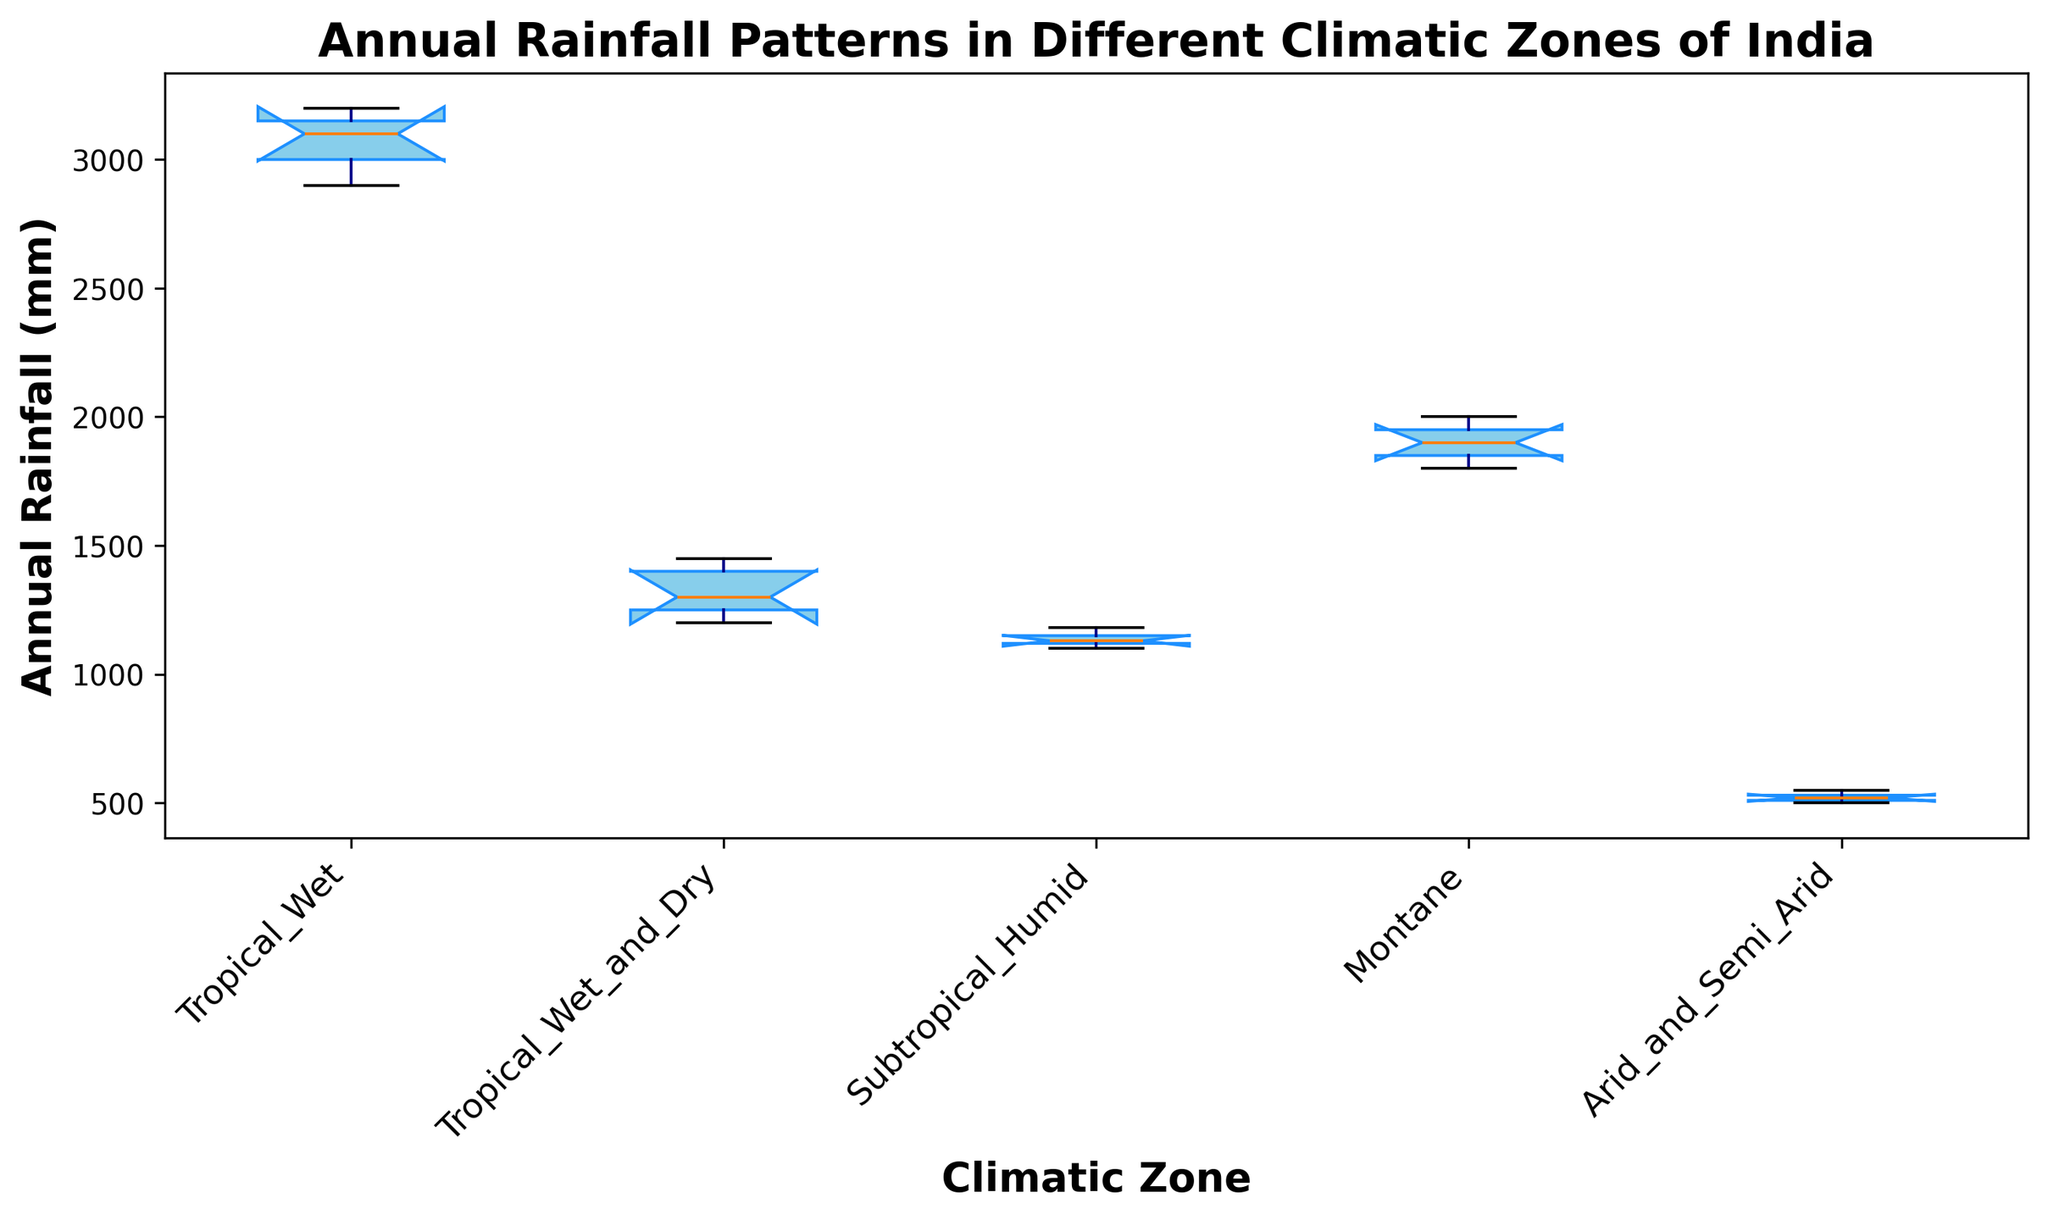What's the median annual rainfall in the Tropical Wet zone? To find the median, we arrange the rainfall values for the Tropical Wet zone in ascending order: 2900, 3000, 3100, 3150, 3200. The median is the middle value, which is 3100.
Answer: 3100 mm Which climatic zone has the highest median annual rainfall? We need to compare the medians of all the climatic zones. From the box plot, the median values are: Tropical Wet: 3100 mm, Tropical Wet and Dry: 1300 mm, Subtropical Humid: 1130 mm, Montane: 1900 mm, Arid and Semi-Arid: 520 mm. The highest median is in the Tropical Wet zone.
Answer: Tropical Wet Which climatic zone shows the largest spread in annual rainfall? The spread is indicated by the length of the box from the first quartile to the third quartile. The Tropical Wet zone has the largest box, showing the largest spread.
Answer: Tropical Wet How does the range of annual rainfall in the Subtropical Humid zone compare to the Montane zone? Range is the difference between the maximum and minimum values. For Subtropical Humid: max 1180 - min 1100 = 80 mm. For Montane: max 2000 - min 1800 = 200 mm. The Montane zone has a larger range.
Answer: Montane What are the lower and upper whiskers' values of annual rainfall in the Arid and Semi-Arid zone? Whiskers represent the minimum and maximum values excluding outliers. From the box plot, the lower whisker is 500 mm and the upper whisker is 550 mm.
Answer: 500 mm and 550 mm Between which climatic zones is the median annual rainfall closest? By comparing the median lines in the boxes, the closest medians are between the Subtropical Humid (1130 mm) and Tropical Wet and Dry (1300 mm) zones.
Answer: Subtropical Humid and Tropical Wet and Dry Which climatic zone has the most consistent annual rainfall? Consistency is indicated by a smaller interquartile range (IQR). The Arid and Semi-Arid zone has the smallest IQR, thus it is the most consistent.
Answer: Arid and Semi-Arid What is the interquartile range (IQR) of annual rainfall in the Montane zone? IQR is the difference between the third quartile (Q3) and the first quartile (Q1). From the box plot for Montane: Q3 ≈ 1950 mm and Q1 ≈ 1850 mm. IQR = 1950 - 1850 = 100 mm.
Answer: 100 mm Which climatic zone has the lowest maximum annual rainfall? The maximum value is indicated by the top whisker. The Arid and Semi-Arid zone has the lowest maximum value at 550 mm.
Answer: Arid and Semi-Arid 